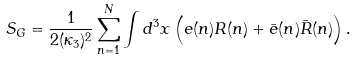Convert formula to latex. <formula><loc_0><loc_0><loc_500><loc_500>S _ { G } = \frac { 1 } { 2 ( \kappa _ { 3 } ) ^ { 2 } } \sum _ { n = 1 } ^ { N } \int d ^ { 3 } x \left ( e ( n ) R ( n ) + \bar { e } ( n ) \bar { R } ( n ) \right ) .</formula> 